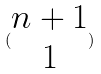<formula> <loc_0><loc_0><loc_500><loc_500>( \begin{matrix} n + 1 \\ 1 \end{matrix} )</formula> 